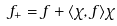<formula> <loc_0><loc_0><loc_500><loc_500>f _ { + } = f + \langle \chi , f \rangle \chi</formula> 